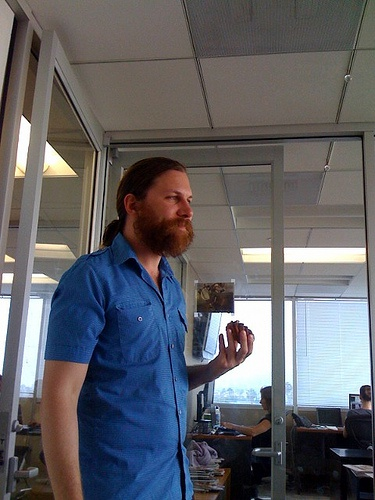Describe the objects in this image and their specific colors. I can see people in gray, navy, black, blue, and maroon tones, people in gray, black, and maroon tones, laptop in gray, black, and purple tones, people in gray and black tones, and donut in gray, black, maroon, brown, and white tones in this image. 